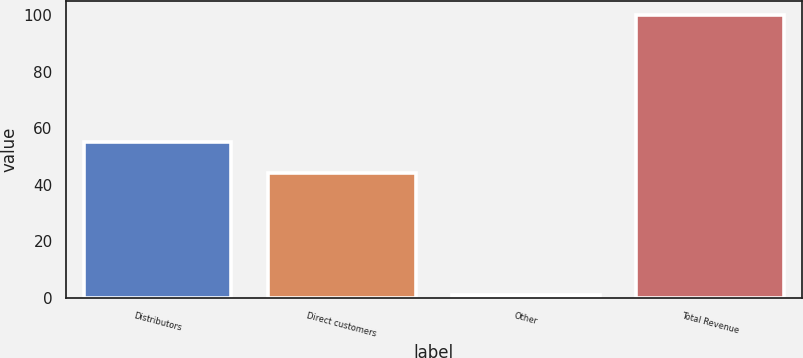<chart> <loc_0><loc_0><loc_500><loc_500><bar_chart><fcel>Distributors<fcel>Direct customers<fcel>Other<fcel>Total Revenue<nl><fcel>55<fcel>44<fcel>1<fcel>100<nl></chart> 